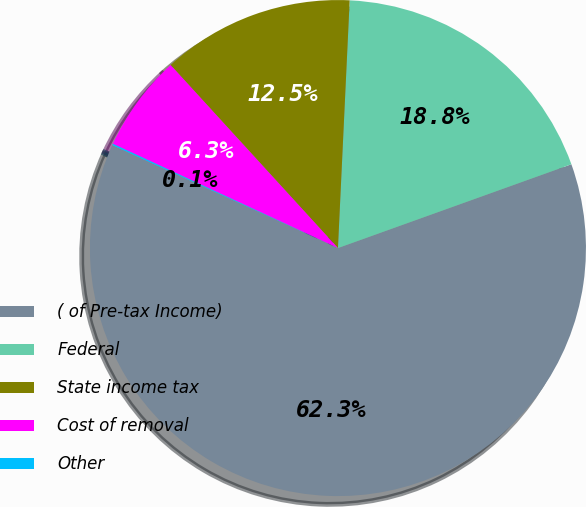<chart> <loc_0><loc_0><loc_500><loc_500><pie_chart><fcel>( of Pre-tax Income)<fcel>Federal<fcel>State income tax<fcel>Cost of removal<fcel>Other<nl><fcel>62.3%<fcel>18.76%<fcel>12.54%<fcel>6.31%<fcel>0.09%<nl></chart> 